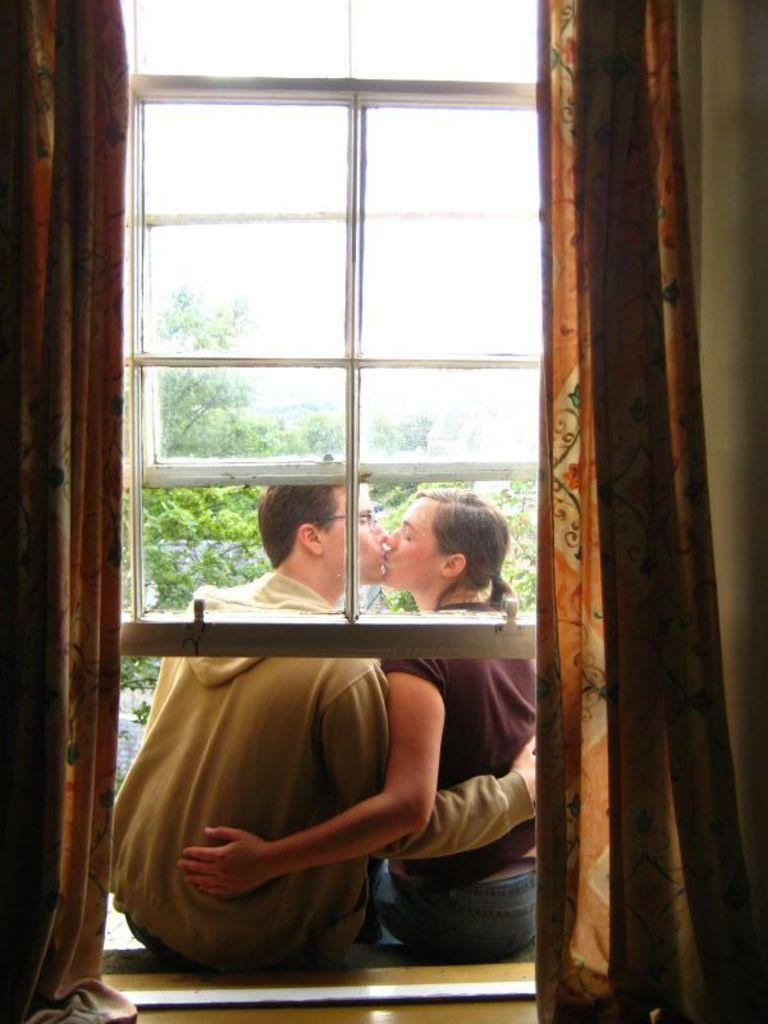How many people are in the image? There are two people in the image, a man and a woman. What are the man and woman doing in the image? The man and woman are holding each other and kissing. What can be seen through the window in the image? Trees are visible through the window in the image. What type of window treatment is present in the image? There are curtains visible in the image. What type of vegetable is being grilled in the image? There is no vegetable being grilled in the image; it features a man and woman holding each other and kissing. Can you see any flames in the image? There are no flames visible in the image. 